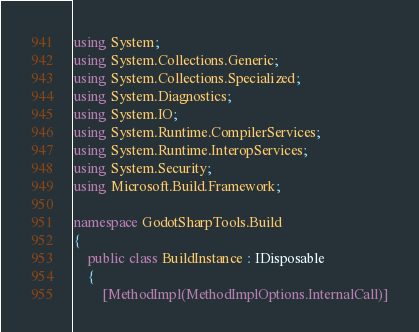<code> <loc_0><loc_0><loc_500><loc_500><_C#_>using System;
using System.Collections.Generic;
using System.Collections.Specialized;
using System.Diagnostics;
using System.IO;
using System.Runtime.CompilerServices;
using System.Runtime.InteropServices;
using System.Security;
using Microsoft.Build.Framework;

namespace GodotSharpTools.Build
{
    public class BuildInstance : IDisposable
    {
        [MethodImpl(MethodImplOptions.InternalCall)]</code> 